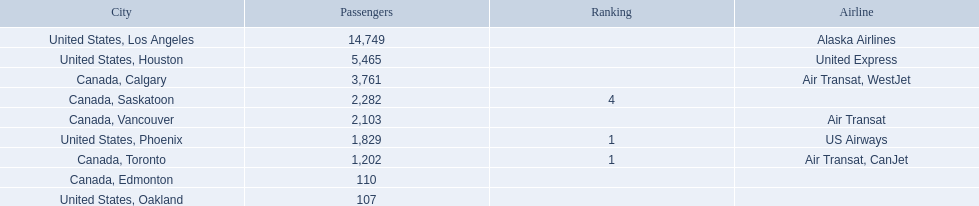What were all the passenger totals? 14,749, 5,465, 3,761, 2,282, 2,103, 1,829, 1,202, 110, 107. Which of these were to los angeles? 14,749. What other destination combined with this is closest to 19,000? Canada, Calgary. 